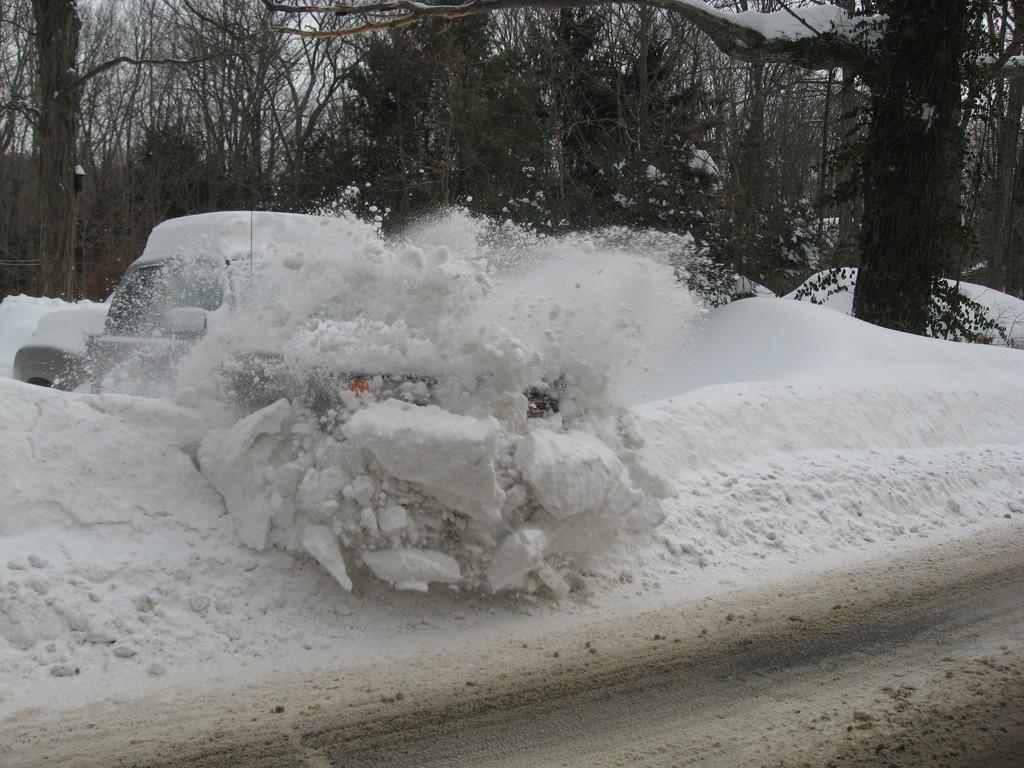How would you summarize this image in a sentence or two? In the image there is snow. And also there is a vehicle covered with snow. In the background there are trees covered with snow. 